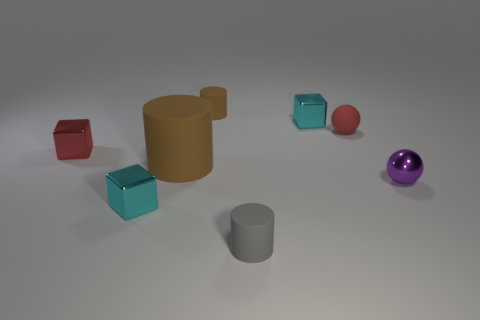Subtract all tiny cyan cubes. How many cubes are left? 1 Subtract all yellow blocks. How many brown cylinders are left? 2 Add 1 small purple balls. How many objects exist? 9 Subtract all blocks. How many objects are left? 5 Subtract all large cylinders. Subtract all gray matte cylinders. How many objects are left? 6 Add 6 small cyan metal objects. How many small cyan metal objects are left? 8 Add 8 small green metallic cylinders. How many small green metallic cylinders exist? 8 Subtract 0 yellow spheres. How many objects are left? 8 